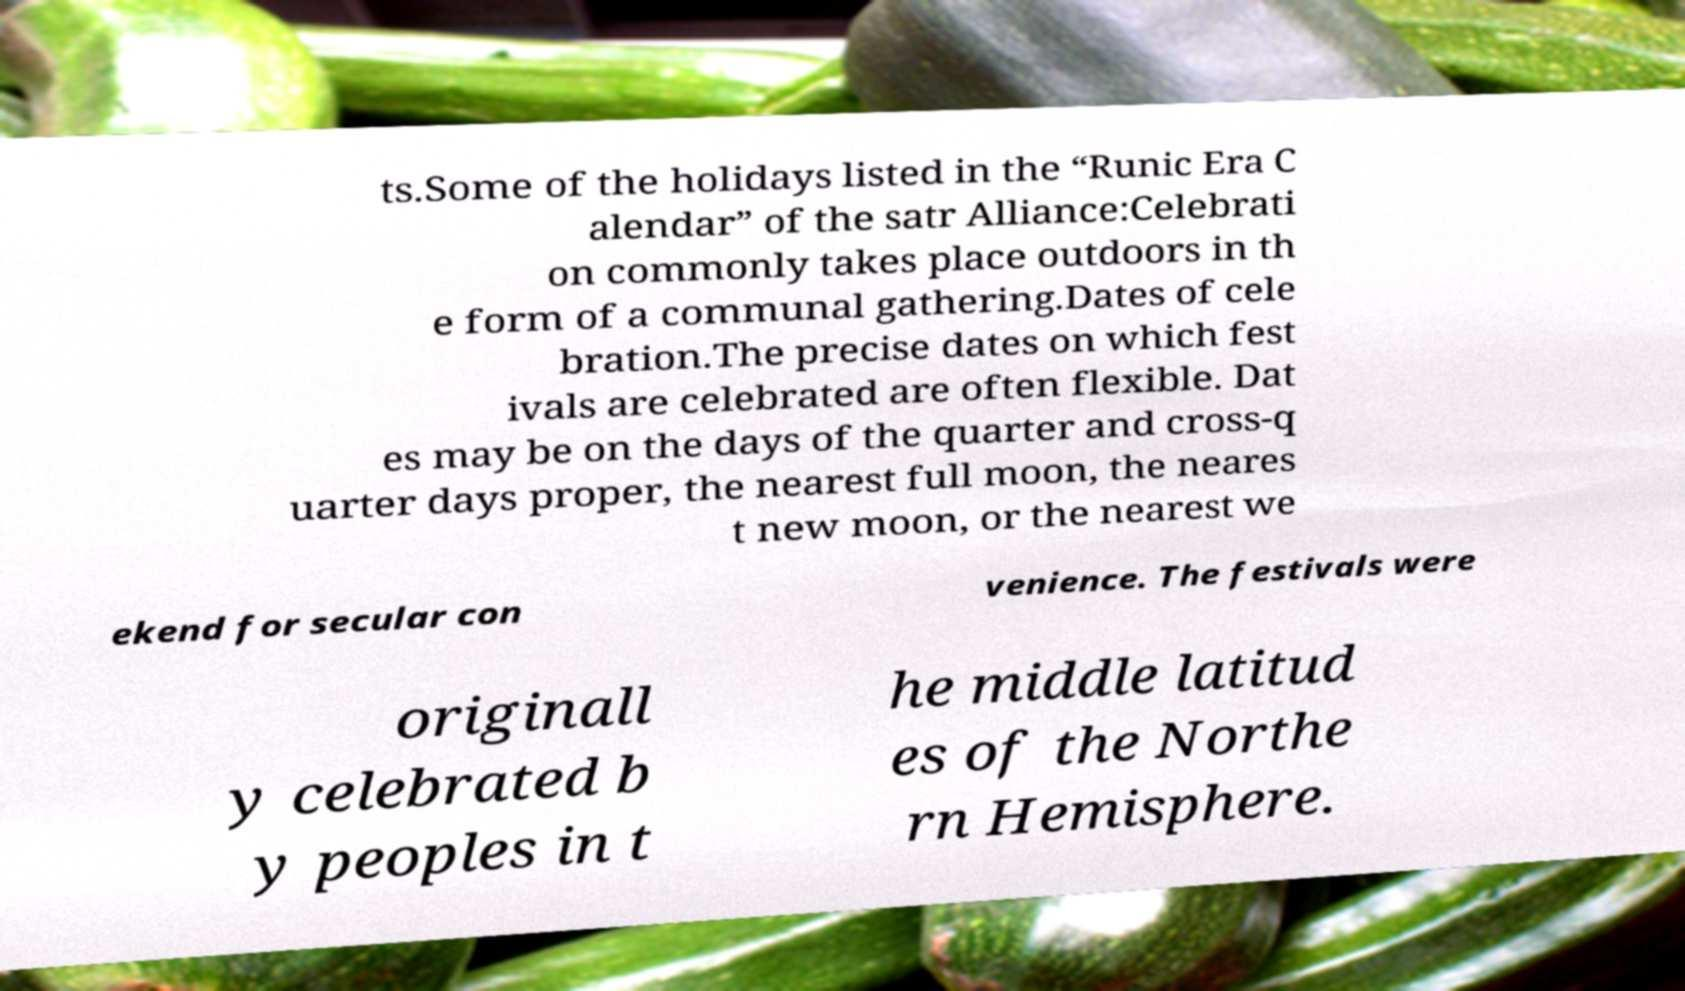Please read and relay the text visible in this image. What does it say? ts.Some of the holidays listed in the “Runic Era C alendar” of the satr Alliance:Celebrati on commonly takes place outdoors in th e form of a communal gathering.Dates of cele bration.The precise dates on which fest ivals are celebrated are often flexible. Dat es may be on the days of the quarter and cross-q uarter days proper, the nearest full moon, the neares t new moon, or the nearest we ekend for secular con venience. The festivals were originall y celebrated b y peoples in t he middle latitud es of the Northe rn Hemisphere. 